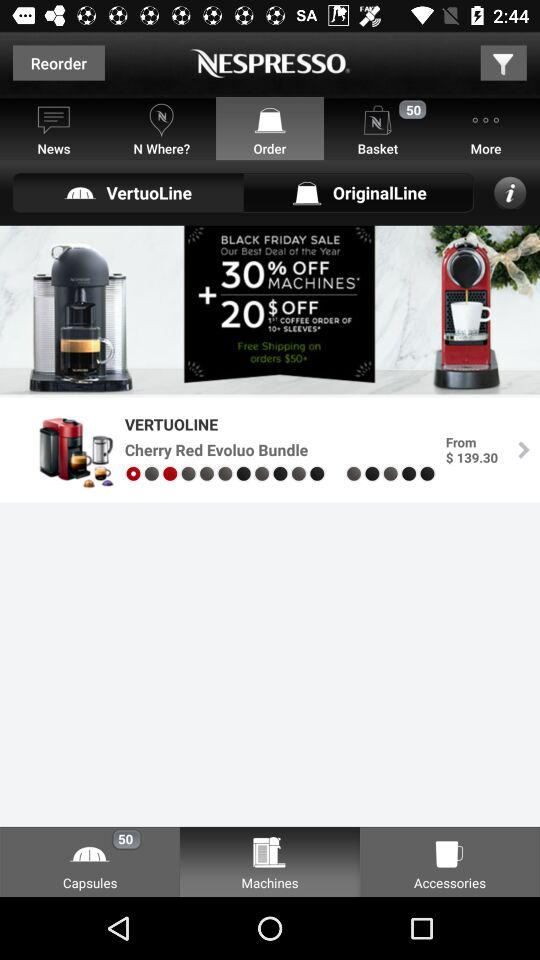How much is the price of the Cherry Red Evoluo Bundle?
Answer the question using a single word or phrase. $139.30 